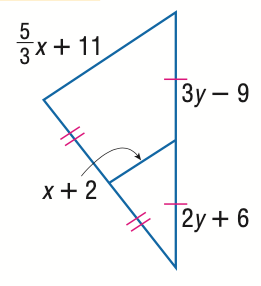Question: Find y.
Choices:
A. 15
B. 18
C. 21
D. 24
Answer with the letter. Answer: A Question: Find x.
Choices:
A. 12
B. 15
C. 18
D. 21
Answer with the letter. Answer: D 